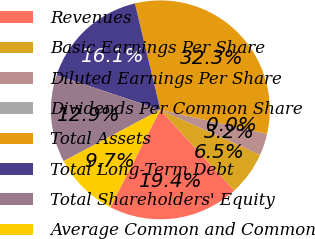Convert chart to OTSL. <chart><loc_0><loc_0><loc_500><loc_500><pie_chart><fcel>Revenues<fcel>Basic Earnings Per Share<fcel>Diluted Earnings Per Share<fcel>Dividends Per Common Share<fcel>Total Assets<fcel>Total Long-Term Debt<fcel>Total Shareholders' Equity<fcel>Average Common and Common<nl><fcel>19.35%<fcel>6.45%<fcel>3.23%<fcel>0.0%<fcel>32.25%<fcel>16.13%<fcel>12.9%<fcel>9.68%<nl></chart> 